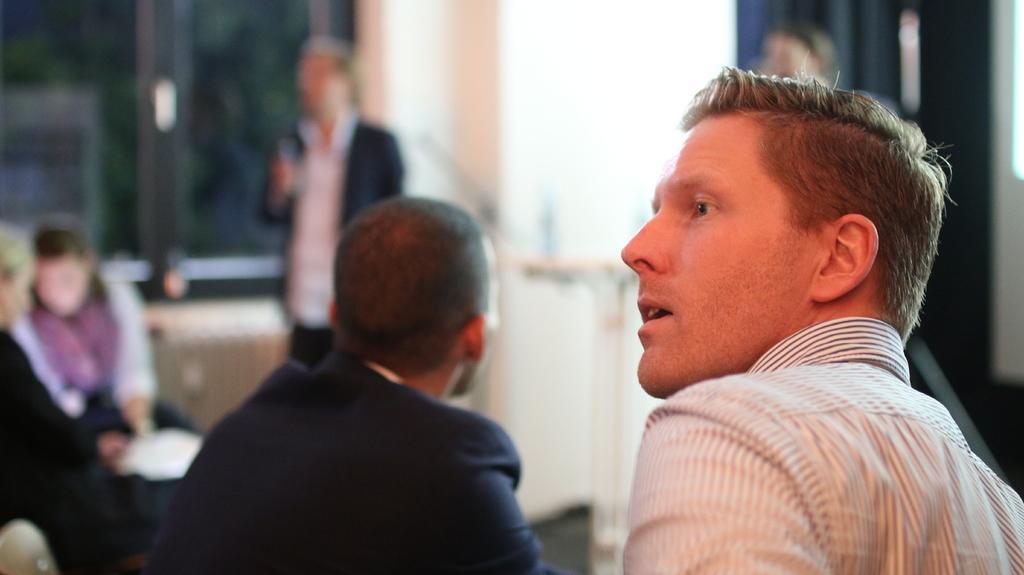How would you summarize this image in a sentence or two? This is the picture of a person and also we can see some other people to the side. 